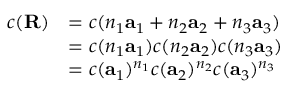<formula> <loc_0><loc_0><loc_500><loc_500>{ \begin{array} { r l } { c ( R ) } & { = c ( n _ { 1 } a _ { 1 } + n _ { 2 } a _ { 2 } + n _ { 3 } a _ { 3 } ) } \\ & { = c ( n _ { 1 } a _ { 1 } ) c ( n _ { 2 } a _ { 2 } ) c ( n _ { 3 } a _ { 3 } ) } \\ & { = c ( a _ { 1 } ) ^ { n _ { 1 } } c ( a _ { 2 } ) ^ { n _ { 2 } } c ( a _ { 3 } ) ^ { n _ { 3 } } } \end{array} }</formula> 